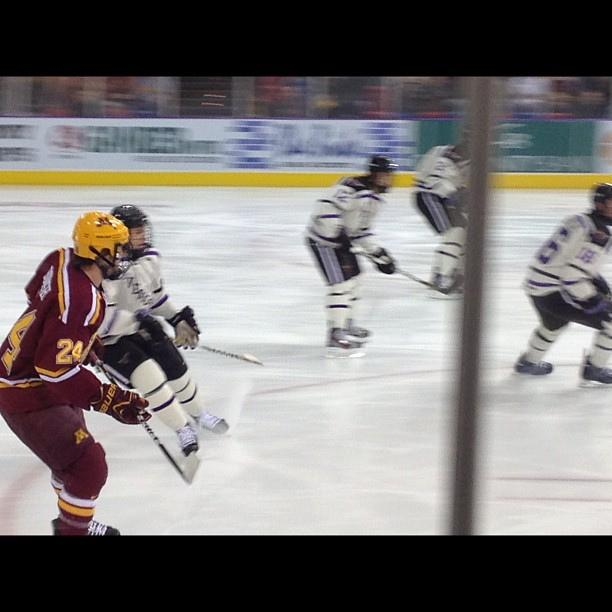What foot appeared are the hockey players wearing to play on the ice? ice skates 